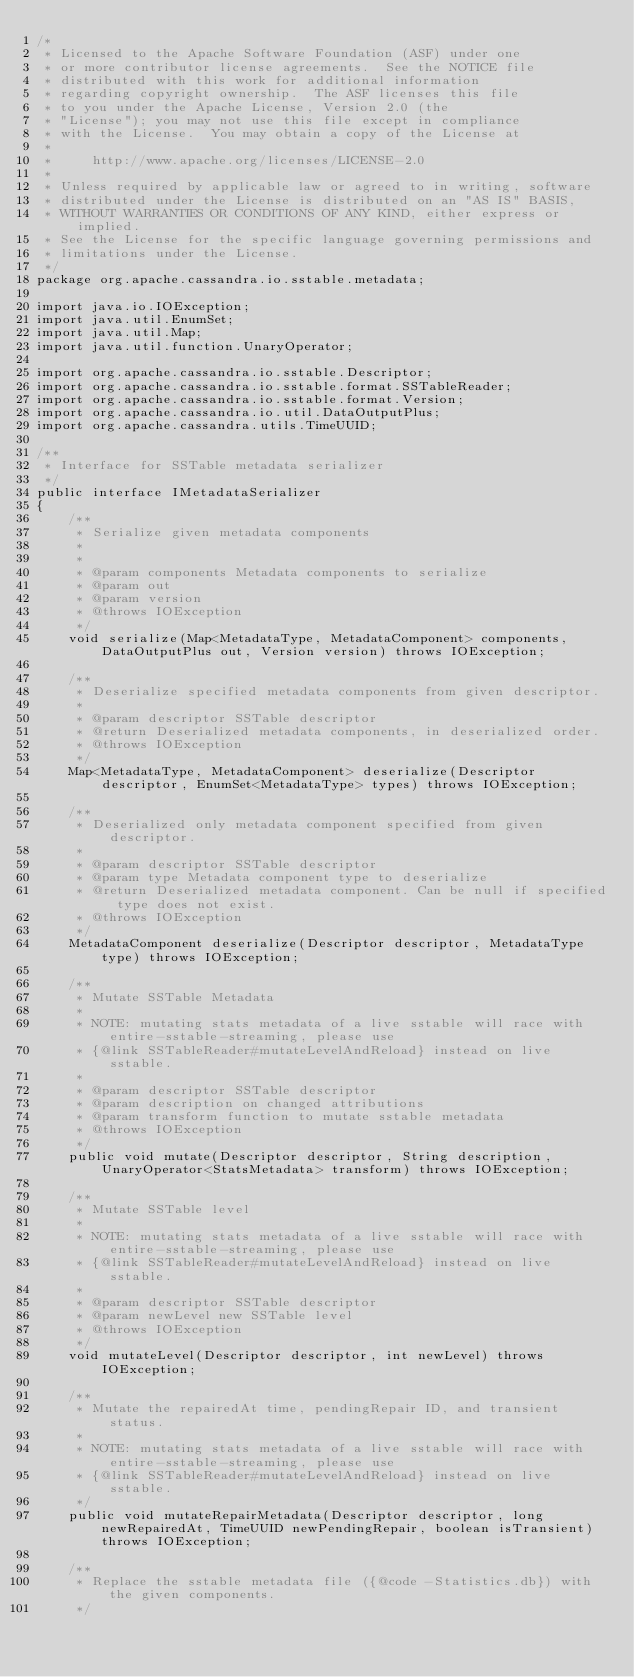Convert code to text. <code><loc_0><loc_0><loc_500><loc_500><_Java_>/*
 * Licensed to the Apache Software Foundation (ASF) under one
 * or more contributor license agreements.  See the NOTICE file
 * distributed with this work for additional information
 * regarding copyright ownership.  The ASF licenses this file
 * to you under the Apache License, Version 2.0 (the
 * "License"); you may not use this file except in compliance
 * with the License.  You may obtain a copy of the License at
 *
 *     http://www.apache.org/licenses/LICENSE-2.0
 *
 * Unless required by applicable law or agreed to in writing, software
 * distributed under the License is distributed on an "AS IS" BASIS,
 * WITHOUT WARRANTIES OR CONDITIONS OF ANY KIND, either express or implied.
 * See the License for the specific language governing permissions and
 * limitations under the License.
 */
package org.apache.cassandra.io.sstable.metadata;

import java.io.IOException;
import java.util.EnumSet;
import java.util.Map;
import java.util.function.UnaryOperator;

import org.apache.cassandra.io.sstable.Descriptor;
import org.apache.cassandra.io.sstable.format.SSTableReader;
import org.apache.cassandra.io.sstable.format.Version;
import org.apache.cassandra.io.util.DataOutputPlus;
import org.apache.cassandra.utils.TimeUUID;

/**
 * Interface for SSTable metadata serializer
 */
public interface IMetadataSerializer
{
    /**
     * Serialize given metadata components
     *
     *
     * @param components Metadata components to serialize
     * @param out
     * @param version
     * @throws IOException
     */
    void serialize(Map<MetadataType, MetadataComponent> components, DataOutputPlus out, Version version) throws IOException;

    /**
     * Deserialize specified metadata components from given descriptor.
     *
     * @param descriptor SSTable descriptor
     * @return Deserialized metadata components, in deserialized order.
     * @throws IOException
     */
    Map<MetadataType, MetadataComponent> deserialize(Descriptor descriptor, EnumSet<MetadataType> types) throws IOException;

    /**
     * Deserialized only metadata component specified from given descriptor.
     *
     * @param descriptor SSTable descriptor
     * @param type Metadata component type to deserialize
     * @return Deserialized metadata component. Can be null if specified type does not exist.
     * @throws IOException
     */
    MetadataComponent deserialize(Descriptor descriptor, MetadataType type) throws IOException;

    /**
     * Mutate SSTable Metadata
     *
     * NOTE: mutating stats metadata of a live sstable will race with entire-sstable-streaming, please use
     * {@link SSTableReader#mutateLevelAndReload} instead on live sstable.
     *
     * @param descriptor SSTable descriptor
     * @param description on changed attributions
     * @param transform function to mutate sstable metadata
     * @throws IOException
     */
    public void mutate(Descriptor descriptor, String description, UnaryOperator<StatsMetadata> transform) throws IOException;

    /**
     * Mutate SSTable level
     *
     * NOTE: mutating stats metadata of a live sstable will race with entire-sstable-streaming, please use
     * {@link SSTableReader#mutateLevelAndReload} instead on live sstable.
     *
     * @param descriptor SSTable descriptor
     * @param newLevel new SSTable level
     * @throws IOException
     */
    void mutateLevel(Descriptor descriptor, int newLevel) throws IOException;

    /**
     * Mutate the repairedAt time, pendingRepair ID, and transient status.
     *
     * NOTE: mutating stats metadata of a live sstable will race with entire-sstable-streaming, please use
     * {@link SSTableReader#mutateLevelAndReload} instead on live sstable.
     */
    public void mutateRepairMetadata(Descriptor descriptor, long newRepairedAt, TimeUUID newPendingRepair, boolean isTransient) throws IOException;

    /**
     * Replace the sstable metadata file ({@code -Statistics.db}) with the given components.
     */</code> 